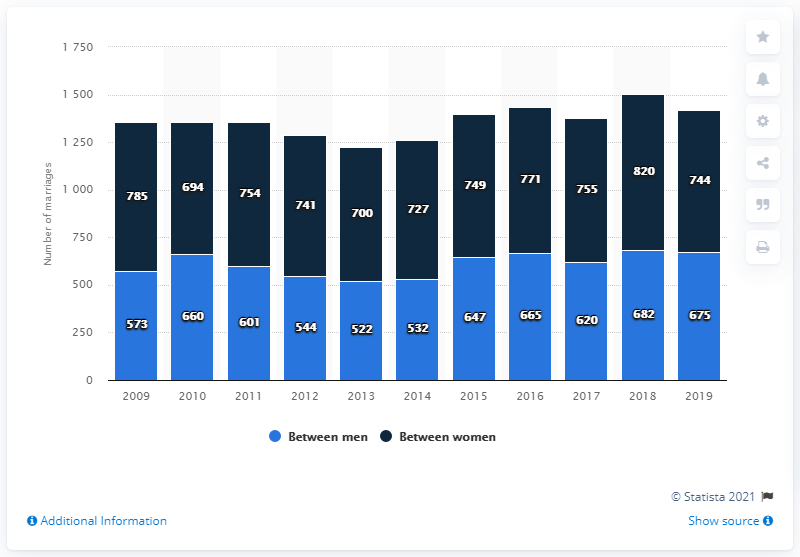What is the sum of 2018 and 2019? The sum of the years 2018 and 2019 is 4037, not 2921 as previously mentioned. 